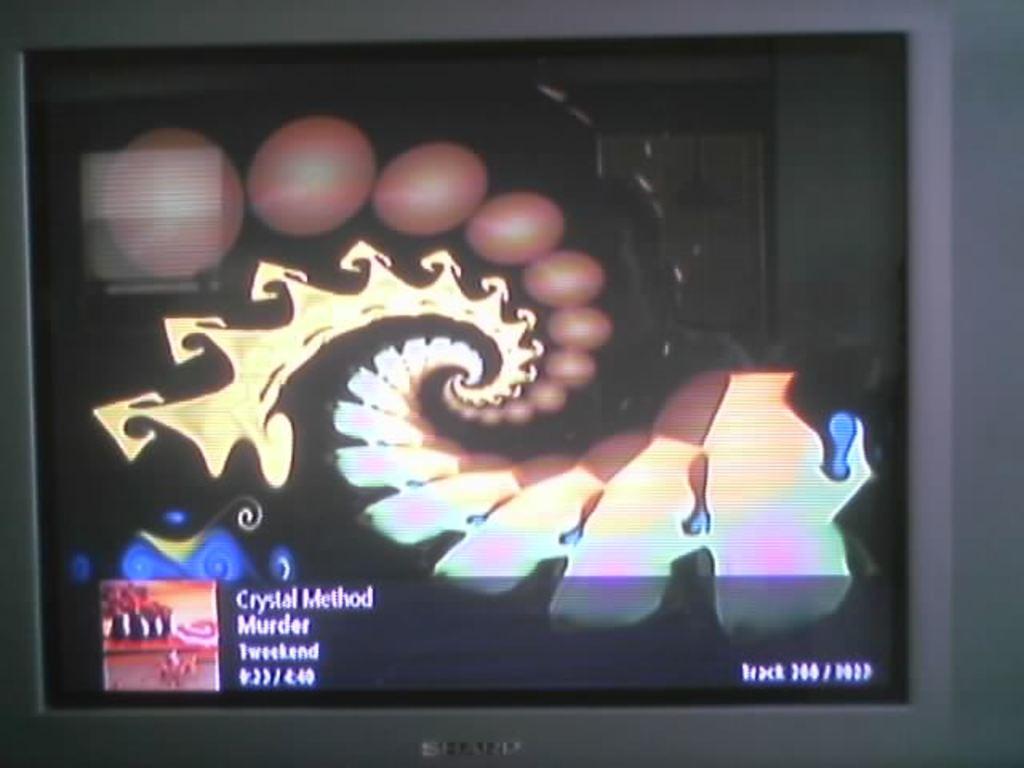What is the name of the album featured on the music channel?
Provide a succinct answer. Tweekend. Who is the musical artist of the album?
Provide a succinct answer. Crystal method. 